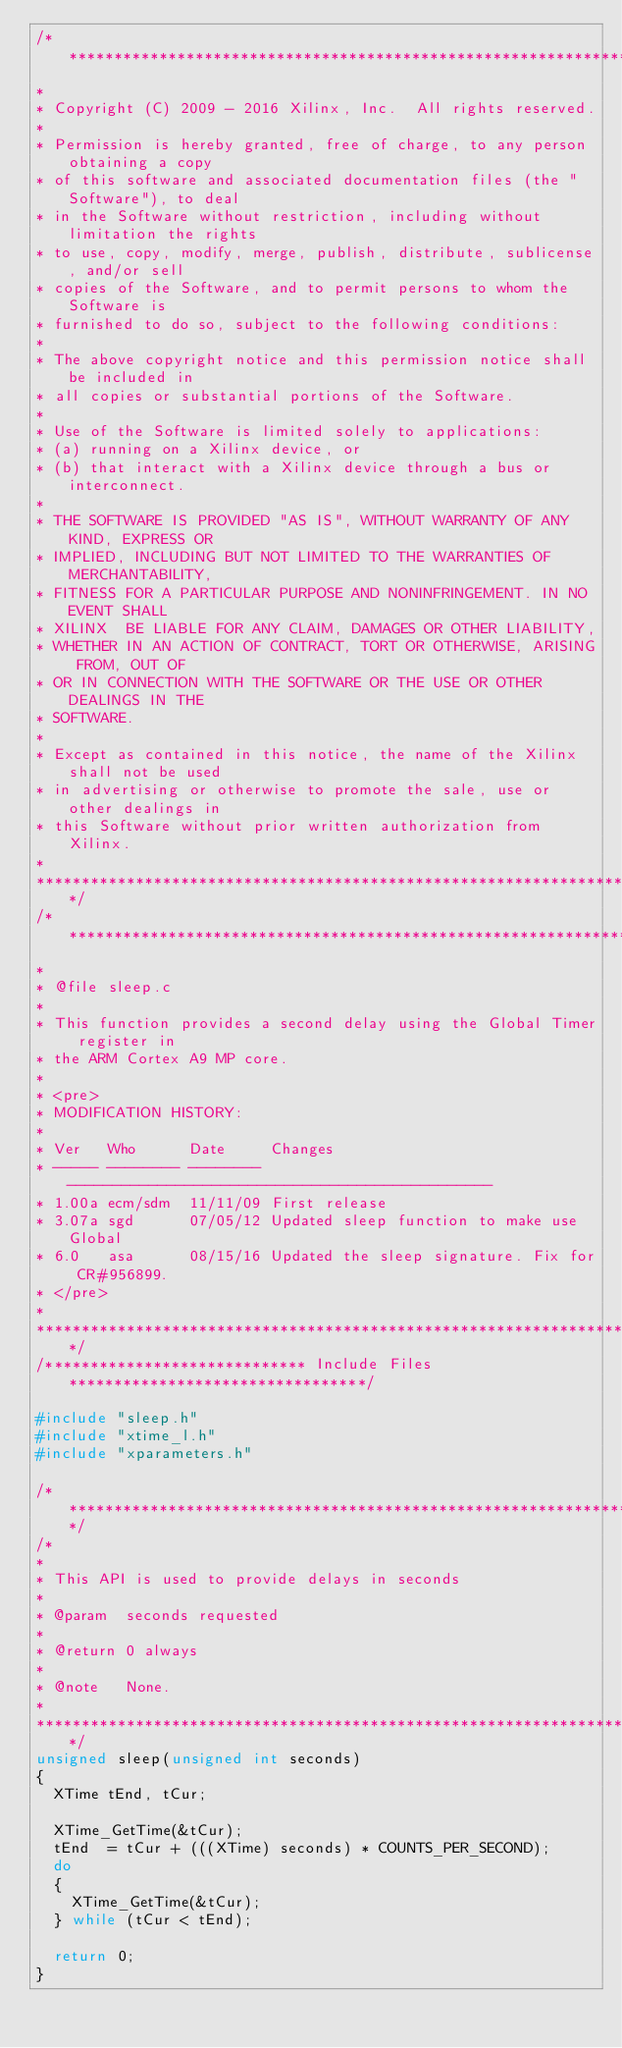<code> <loc_0><loc_0><loc_500><loc_500><_C_>/******************************************************************************
*
* Copyright (C) 2009 - 2016 Xilinx, Inc.  All rights reserved.
*
* Permission is hereby granted, free of charge, to any person obtaining a copy
* of this software and associated documentation files (the "Software"), to deal
* in the Software without restriction, including without limitation the rights
* to use, copy, modify, merge, publish, distribute, sublicense, and/or sell
* copies of the Software, and to permit persons to whom the Software is
* furnished to do so, subject to the following conditions:
*
* The above copyright notice and this permission notice shall be included in
* all copies or substantial portions of the Software.
*
* Use of the Software is limited solely to applications:
* (a) running on a Xilinx device, or
* (b) that interact with a Xilinx device through a bus or interconnect.
*
* THE SOFTWARE IS PROVIDED "AS IS", WITHOUT WARRANTY OF ANY KIND, EXPRESS OR
* IMPLIED, INCLUDING BUT NOT LIMITED TO THE WARRANTIES OF MERCHANTABILITY,
* FITNESS FOR A PARTICULAR PURPOSE AND NONINFRINGEMENT. IN NO EVENT SHALL
* XILINX  BE LIABLE FOR ANY CLAIM, DAMAGES OR OTHER LIABILITY,
* WHETHER IN AN ACTION OF CONTRACT, TORT OR OTHERWISE, ARISING FROM, OUT OF
* OR IN CONNECTION WITH THE SOFTWARE OR THE USE OR OTHER DEALINGS IN THE
* SOFTWARE.
*
* Except as contained in this notice, the name of the Xilinx shall not be used
* in advertising or otherwise to promote the sale, use or other dealings in
* this Software without prior written authorization from Xilinx.
*
******************************************************************************/
/*****************************************************************************
*
* @file sleep.c
*
* This function provides a second delay using the Global Timer register in
* the ARM Cortex A9 MP core.
*
* <pre>
* MODIFICATION HISTORY:
*
* Ver   Who      Date     Changes
* ----- -------- -------- -----------------------------------------------
* 1.00a ecm/sdm  11/11/09 First release
* 3.07a sgd      07/05/12 Updated sleep function to make use Global
* 6.0   asa      08/15/16 Updated the sleep signature. Fix for CR#956899.
* </pre>
*
******************************************************************************/
/***************************** Include Files *********************************/

#include "sleep.h"
#include "xtime_l.h"
#include "xparameters.h"

/*****************************************************************************/
/*
*
* This API is used to provide delays in seconds
*
* @param	seconds requested
*
* @return	0 always
*
* @note		None.
*
****************************************************************************/
unsigned sleep(unsigned int seconds)
{
  XTime tEnd, tCur;

  XTime_GetTime(&tCur);
  tEnd  = tCur + (((XTime) seconds) * COUNTS_PER_SECOND);
  do
  {
    XTime_GetTime(&tCur);
  } while (tCur < tEnd);

  return 0;
}
</code> 